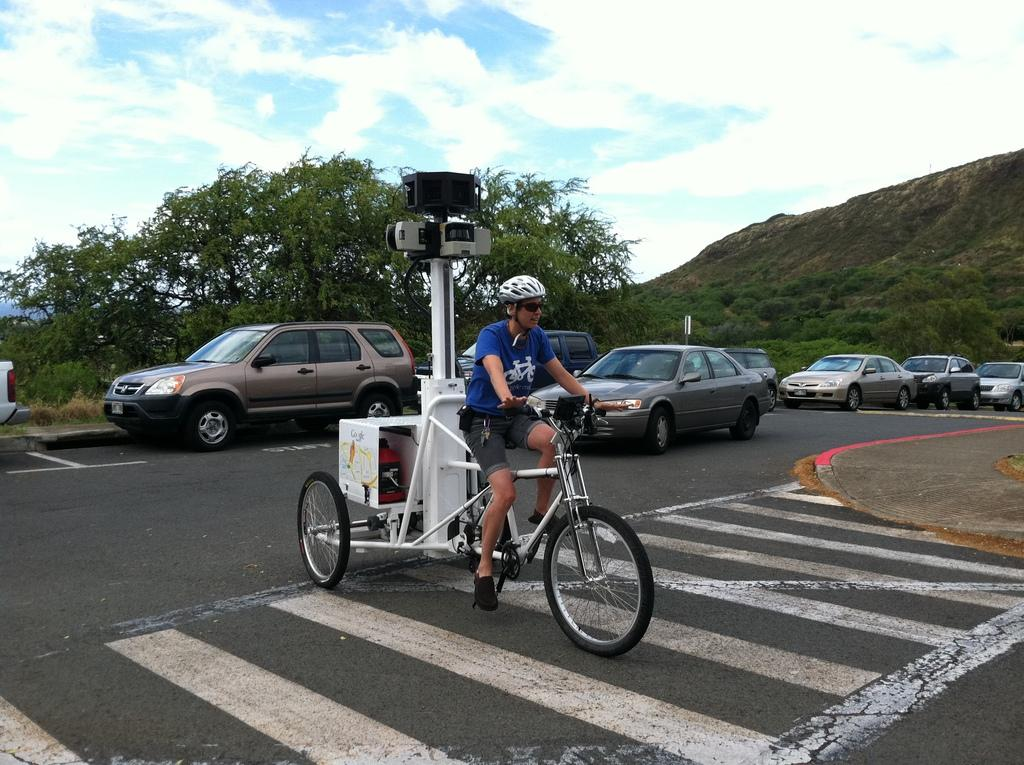Who is the main subject in the image? There is a man in the image. What is the man doing in the image? The man is riding a tricycle. What objects can be seen in the image besides the man and the tricycle? There are cameras visible in the image. What can be seen in the background of the image? There are cars, trees, and clouds in the background of the image. What type of frame is the man using to ride the tricycle in the image? The man is not using a frame to ride the tricycle in the image; he is simply riding it. Can you tell me how many bottles are visible in the image? There are no bottles visible in the image. 